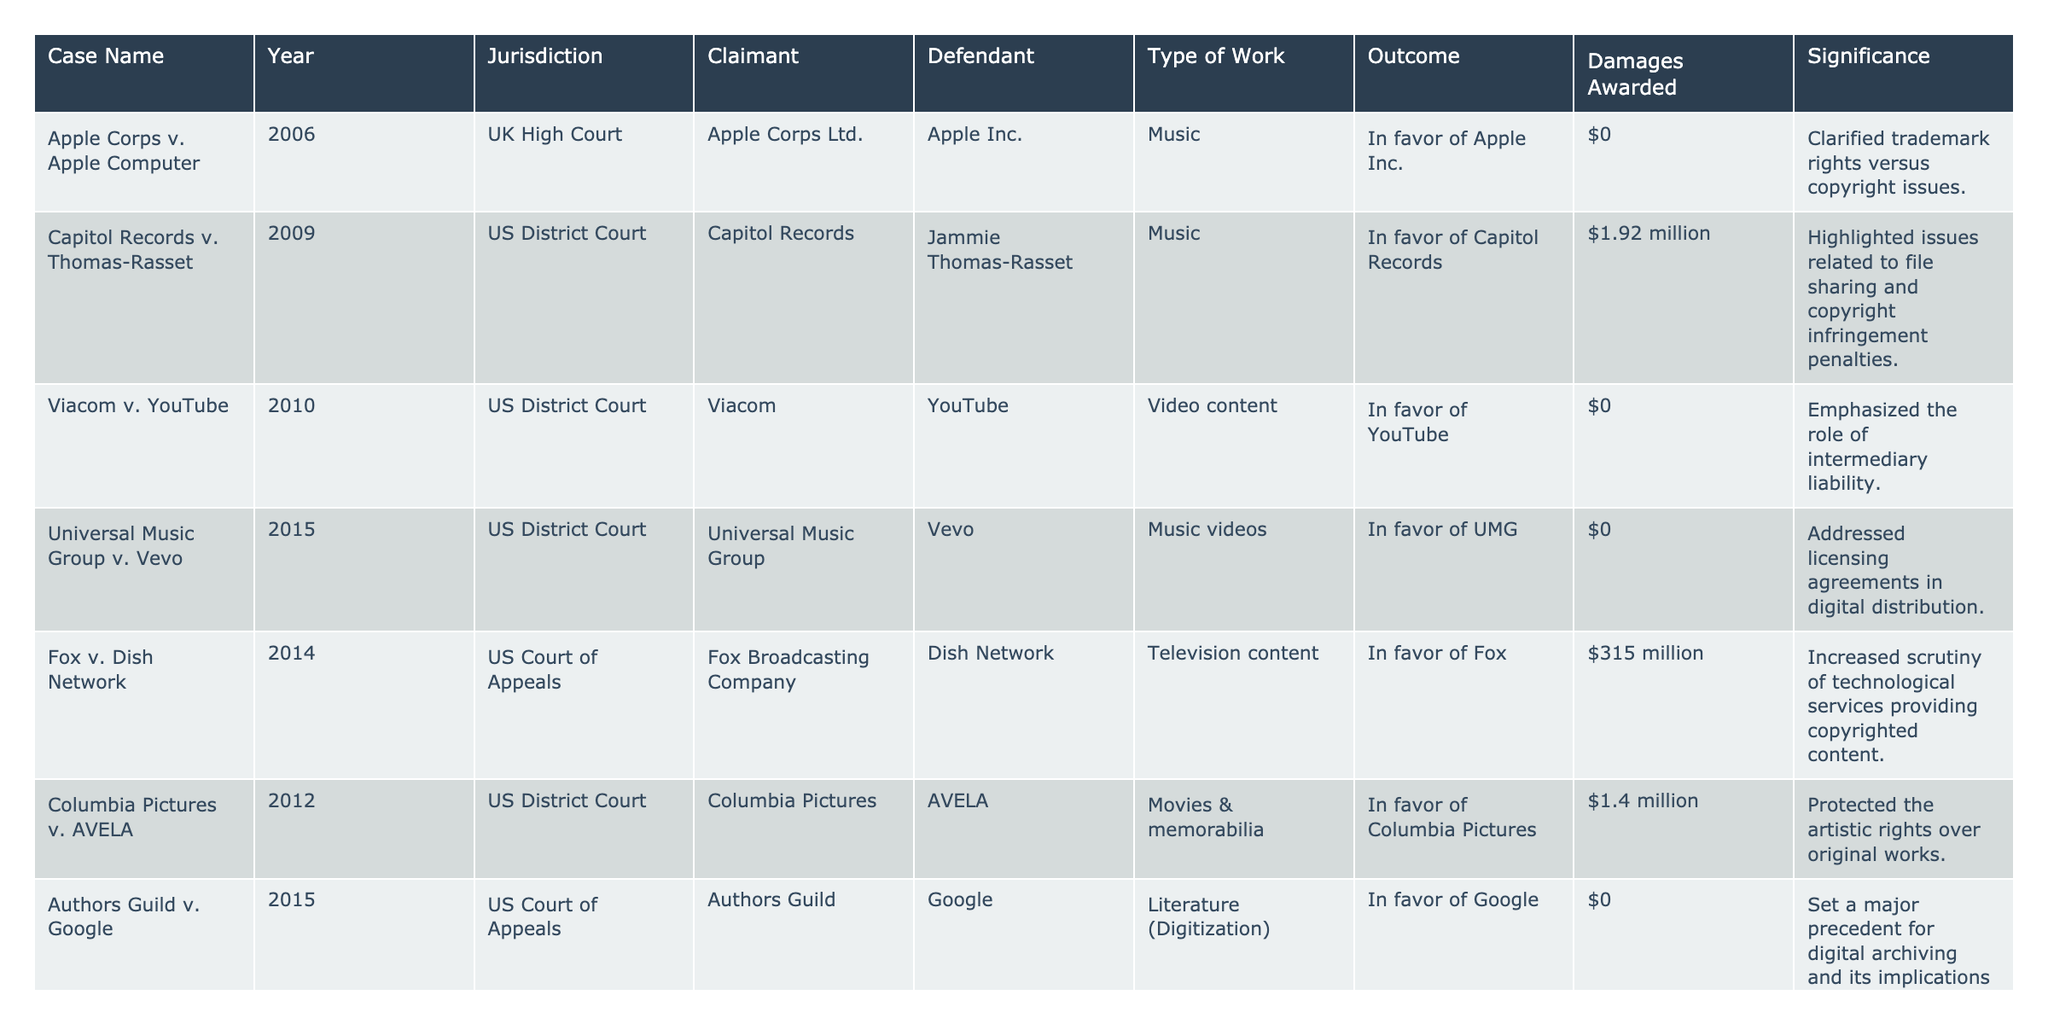What was the outcome of the "Capitol Records v. Thomas-Rasset" case? The table states that the outcome was "In favor of Capitol Records."
Answer: In favor of Capitol Records Which case had the highest damages awarded, and what was the amount? The case "Fox v. Dish Network" had the highest damages awarded at $315 million, as seen in the "Damages Awarded" column.
Answer: $315 million Did any case result in damages being awarded to the defendant? The table shows no instances where the defendant received damages awarded; all outcomes were in favor of the claimant or resulted in $0 damages.
Answer: No What significance is associated with the "Authors Guild v. Google" case? The table states its significance as setting a major precedent for digital archiving and its implications for copyright law, found in the "Significance" column.
Answer: Major precedent for digital archiving How many cases resulted in a $0 damages award? By reviewing the "Damages Awarded" column, I count four cases that resulted in $0 damages: "Apple Corps v. Apple Computer," "Viacom v. YouTube," "Universal Music Group v. Vevo," and "Authors Guild v. Google."
Answer: 4 Which jurisdiction had the most notable cases listed in the table? Upon reviewing the table, the "US District Court" appears three times, indicating that it had the most cases relative to other jurisdictions.
Answer: US District Court Which case involved the issue of transformative use? The "Mattel v. MCA Records" case is highlighted in the significance column as reinforcing the idea of transformative use in fair use analysis.
Answer: Mattel v. MCA Records What year did the "Reed Elsevier v. Muchnick" case occur, and what was its outcome? The case occurred in 2010, and its outcome was "In favor of Reed Elsevier," as indicated in the respective columns.
Answer: 2010, In favor of Reed Elsevier Identify the two cases that involved music as the type of work and explain their outcomes. The two cases are "Capitol Records v. Thomas-Rasset," which was in favor of Capitol Records, and "Mattel v. MCA Records," which was in favor of MCA Records.
Answer: Capitol Records v. Thomas-Rasset: In favor of Capitol Records; Mattel v. MCA Records: In favor of MCA Records Which case addressed issues related to file sharing? The "Capitol Records v. Thomas-Rasset" case is noted for highlighting issues related to file sharing and copyright infringement penalties, as mentioned in the significance column.
Answer: Capitol Records v. Thomas-Rasset 